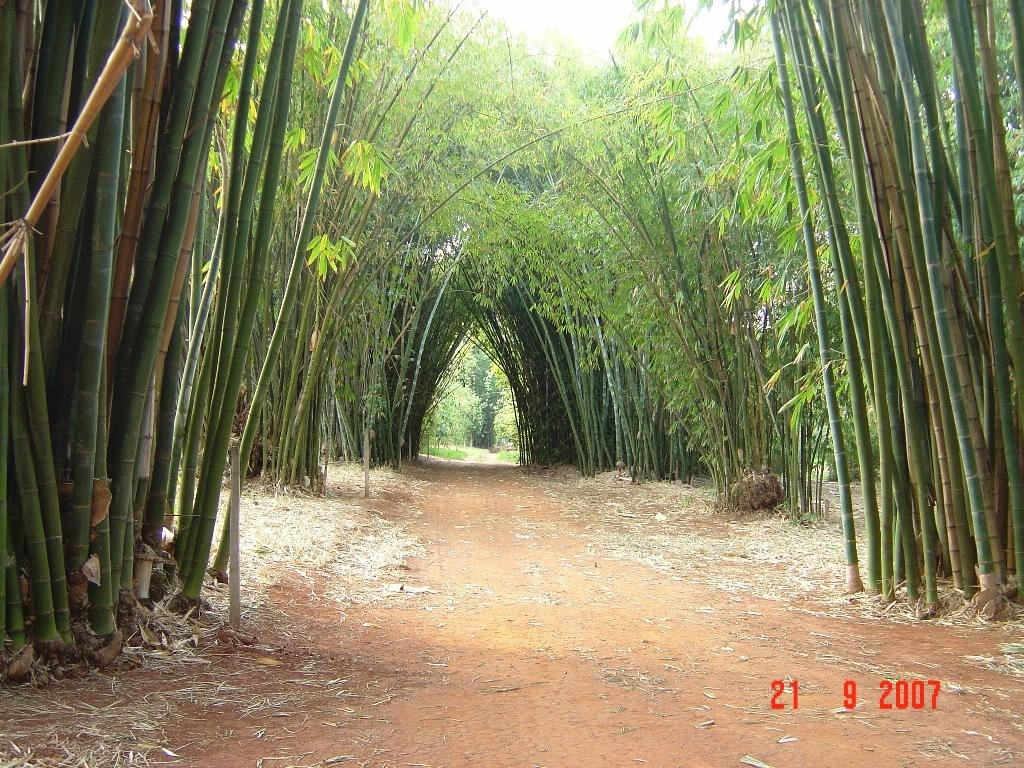What type of vegetation can be seen in the image? There are trees in the image. What else can be seen on the ground in the image? There is grass in the image. Is there any indication of a path or trail in the image? Yes, there is a path in the image. What is visible in the background of the image? The sky is visible in the background of the image. What type of wrist accessory is visible on the trees in the image? There are no wrist accessories present on the trees in the image. What type of calculator can be seen in the image? There is no calculator present in the image. 